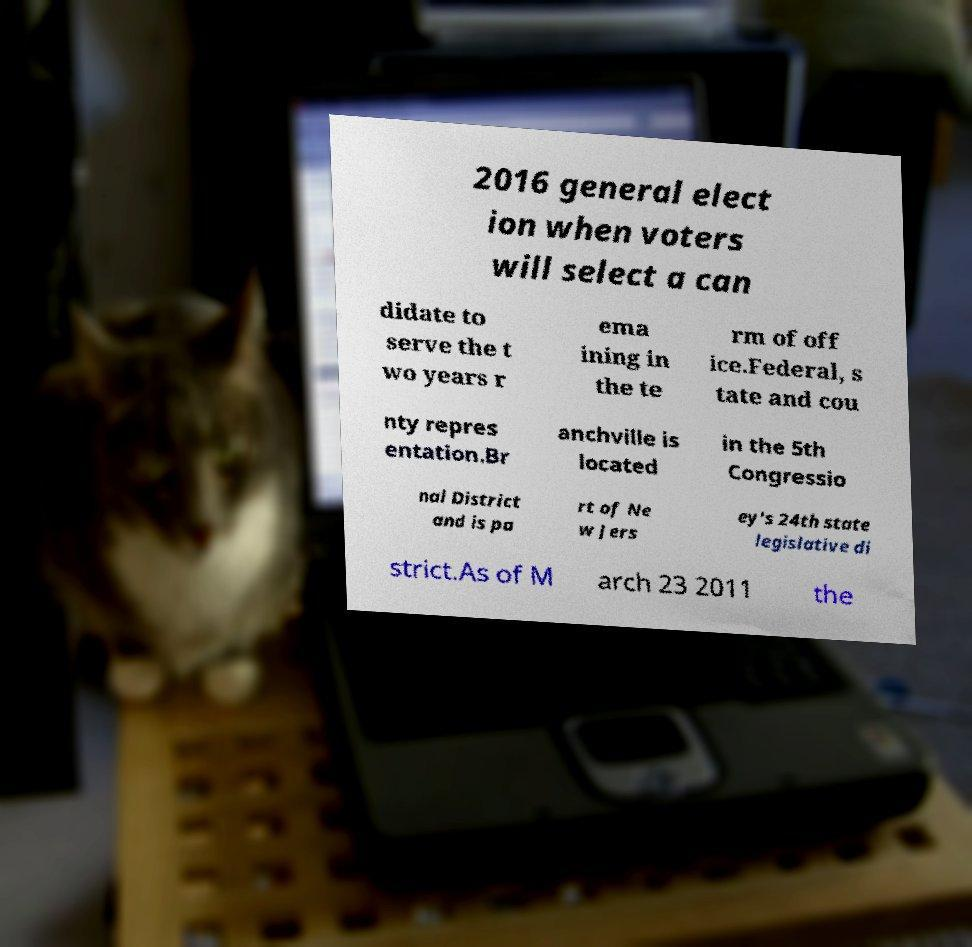Can you accurately transcribe the text from the provided image for me? 2016 general elect ion when voters will select a can didate to serve the t wo years r ema ining in the te rm of off ice.Federal, s tate and cou nty repres entation.Br anchville is located in the 5th Congressio nal District and is pa rt of Ne w Jers ey's 24th state legislative di strict.As of M arch 23 2011 the 